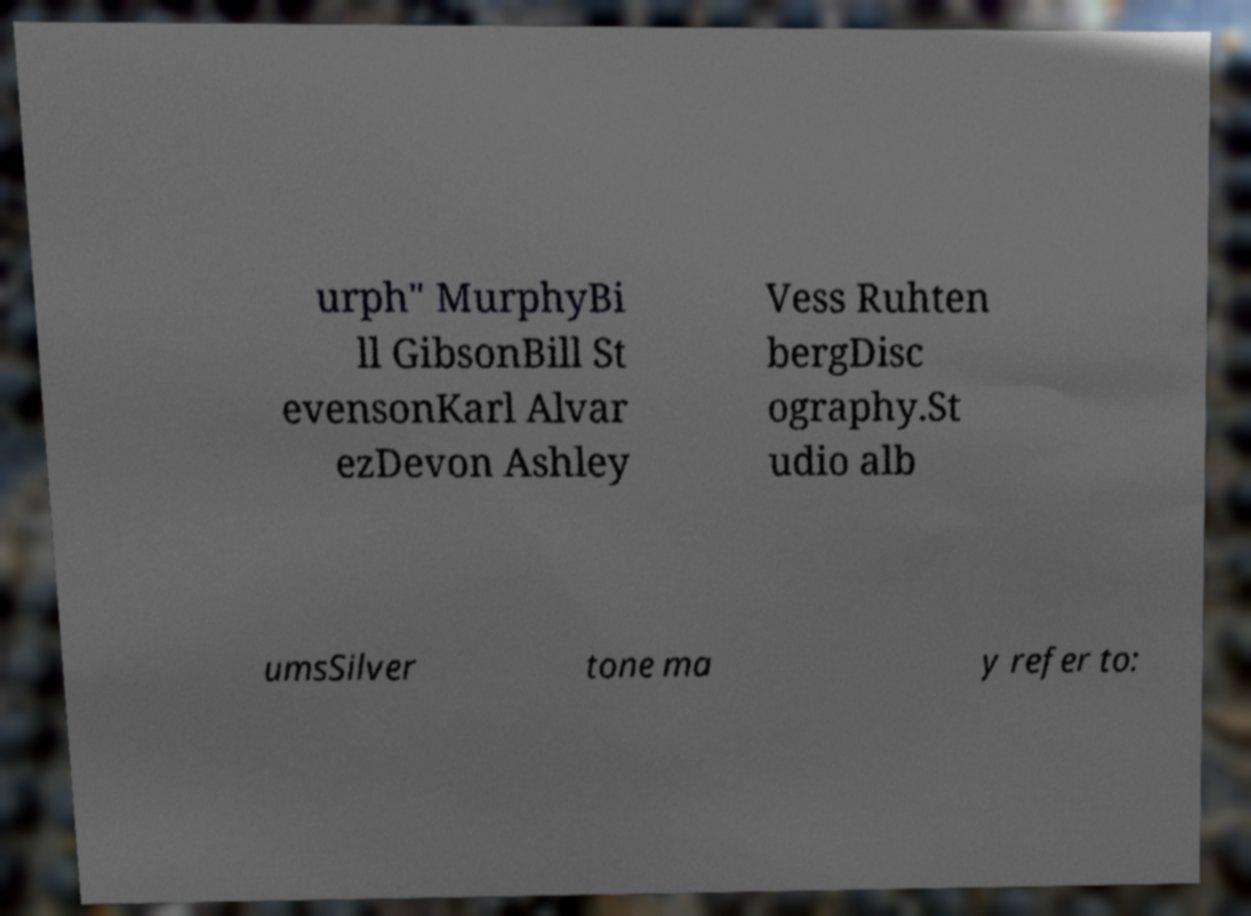Can you read and provide the text displayed in the image?This photo seems to have some interesting text. Can you extract and type it out for me? urph" MurphyBi ll GibsonBill St evensonKarl Alvar ezDevon Ashley Vess Ruhten bergDisc ography.St udio alb umsSilver tone ma y refer to: 